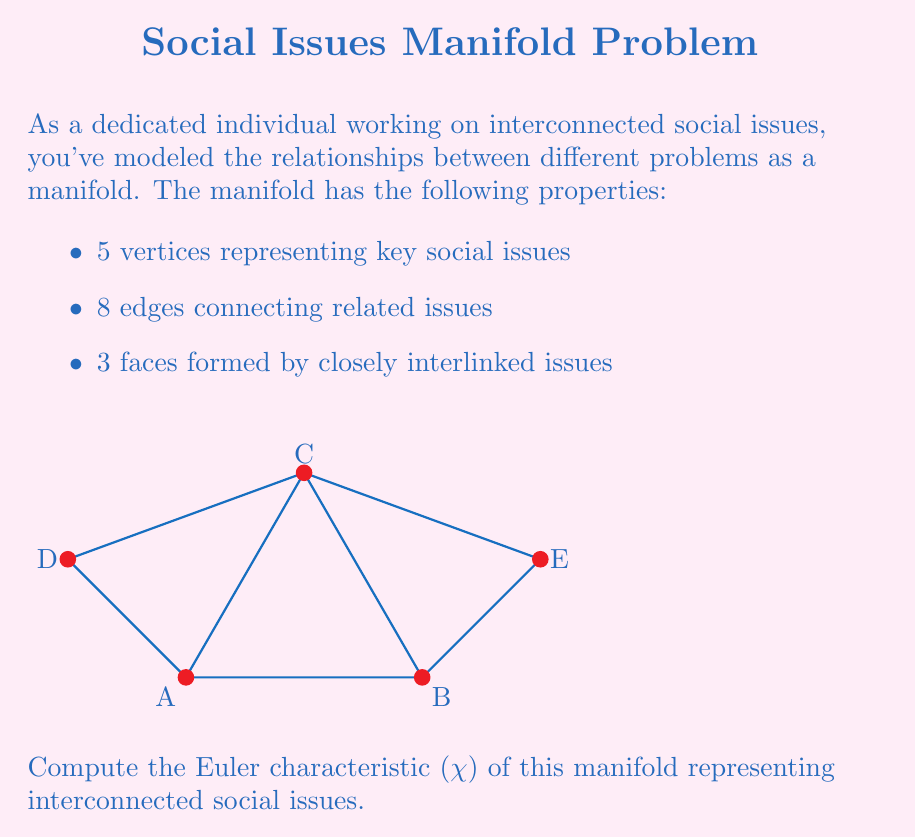Solve this math problem. To compute the Euler characteristic of this manifold, we'll use the formula:

$$\chi = V - E + F$$

Where:
$V$ = number of vertices
$E$ = number of edges
$F$ = number of faces

Let's identify each component:

1. Vertices ($V$): The question states there are 5 vertices representing key social issues.

2. Edges ($E$): There are 8 edges connecting related issues.

3. Faces ($F$): The manifold has 3 faces formed by closely interlinked issues.

Now, let's substitute these values into the Euler characteristic formula:

$$\chi = V - E + F$$
$$\chi = 5 - 8 + 3$$

Calculating:
$$\chi = 0$$

The Euler characteristic of this manifold is 0.

This result is significant in the context of social issues. An Euler characteristic of 0 often indicates a topological structure similar to a torus, suggesting a complex, interconnected system where issues are cyclically linked. This reinforces the idea that social problems are often deeply interrelated and addressing one issue may have ripple effects on others.
Answer: $\chi = 0$ 